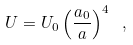<formula> <loc_0><loc_0><loc_500><loc_500>U = U _ { 0 } \left ( \frac { a _ { 0 } } { a } \right ) ^ { 4 } \ ,</formula> 